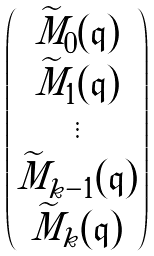Convert formula to latex. <formula><loc_0><loc_0><loc_500><loc_500>\begin{pmatrix} \widetilde { M } _ { 0 } ( \mathfrak { q } ) \\ \widetilde { M } _ { 1 } ( \mathfrak { q } ) \\ \vdots \\ \widetilde { M } _ { k - 1 } ( \mathfrak { q } ) \\ \widetilde { M } _ { k } ( \mathfrak { q } ) \end{pmatrix}</formula> 